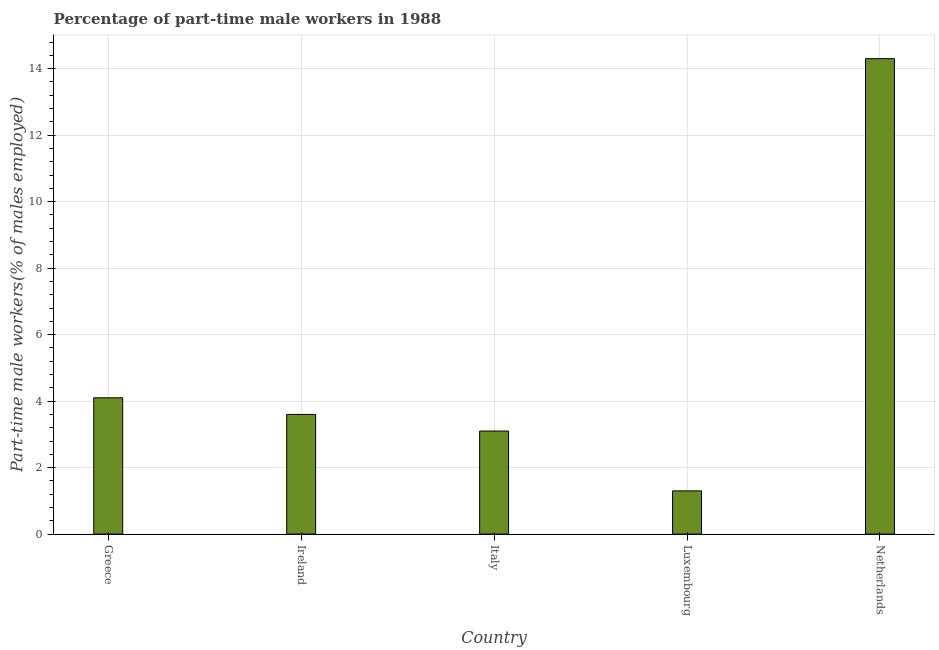Does the graph contain any zero values?
Offer a very short reply. No. What is the title of the graph?
Provide a succinct answer. Percentage of part-time male workers in 1988. What is the label or title of the Y-axis?
Ensure brevity in your answer.  Part-time male workers(% of males employed). What is the percentage of part-time male workers in Italy?
Provide a succinct answer. 3.1. Across all countries, what is the maximum percentage of part-time male workers?
Your response must be concise. 14.3. Across all countries, what is the minimum percentage of part-time male workers?
Make the answer very short. 1.3. In which country was the percentage of part-time male workers minimum?
Make the answer very short. Luxembourg. What is the sum of the percentage of part-time male workers?
Ensure brevity in your answer.  26.4. What is the average percentage of part-time male workers per country?
Offer a terse response. 5.28. What is the median percentage of part-time male workers?
Keep it short and to the point. 3.6. What is the ratio of the percentage of part-time male workers in Luxembourg to that in Netherlands?
Your answer should be very brief. 0.09. Is the difference between the percentage of part-time male workers in Italy and Netherlands greater than the difference between any two countries?
Ensure brevity in your answer.  No. Is the sum of the percentage of part-time male workers in Greece and Ireland greater than the maximum percentage of part-time male workers across all countries?
Offer a terse response. No. Are all the bars in the graph horizontal?
Make the answer very short. No. How many countries are there in the graph?
Your answer should be very brief. 5. Are the values on the major ticks of Y-axis written in scientific E-notation?
Provide a short and direct response. No. What is the Part-time male workers(% of males employed) of Greece?
Make the answer very short. 4.1. What is the Part-time male workers(% of males employed) in Ireland?
Your answer should be compact. 3.6. What is the Part-time male workers(% of males employed) of Italy?
Provide a succinct answer. 3.1. What is the Part-time male workers(% of males employed) of Luxembourg?
Your answer should be compact. 1.3. What is the Part-time male workers(% of males employed) of Netherlands?
Your answer should be very brief. 14.3. What is the difference between the Part-time male workers(% of males employed) in Greece and Luxembourg?
Provide a succinct answer. 2.8. What is the difference between the Part-time male workers(% of males employed) in Greece and Netherlands?
Your answer should be compact. -10.2. What is the difference between the Part-time male workers(% of males employed) in Ireland and Luxembourg?
Keep it short and to the point. 2.3. What is the difference between the Part-time male workers(% of males employed) in Italy and Luxembourg?
Keep it short and to the point. 1.8. What is the difference between the Part-time male workers(% of males employed) in Luxembourg and Netherlands?
Offer a very short reply. -13. What is the ratio of the Part-time male workers(% of males employed) in Greece to that in Ireland?
Offer a terse response. 1.14. What is the ratio of the Part-time male workers(% of males employed) in Greece to that in Italy?
Offer a terse response. 1.32. What is the ratio of the Part-time male workers(% of males employed) in Greece to that in Luxembourg?
Ensure brevity in your answer.  3.15. What is the ratio of the Part-time male workers(% of males employed) in Greece to that in Netherlands?
Give a very brief answer. 0.29. What is the ratio of the Part-time male workers(% of males employed) in Ireland to that in Italy?
Offer a terse response. 1.16. What is the ratio of the Part-time male workers(% of males employed) in Ireland to that in Luxembourg?
Keep it short and to the point. 2.77. What is the ratio of the Part-time male workers(% of males employed) in Ireland to that in Netherlands?
Your answer should be compact. 0.25. What is the ratio of the Part-time male workers(% of males employed) in Italy to that in Luxembourg?
Keep it short and to the point. 2.38. What is the ratio of the Part-time male workers(% of males employed) in Italy to that in Netherlands?
Provide a short and direct response. 0.22. What is the ratio of the Part-time male workers(% of males employed) in Luxembourg to that in Netherlands?
Provide a succinct answer. 0.09. 